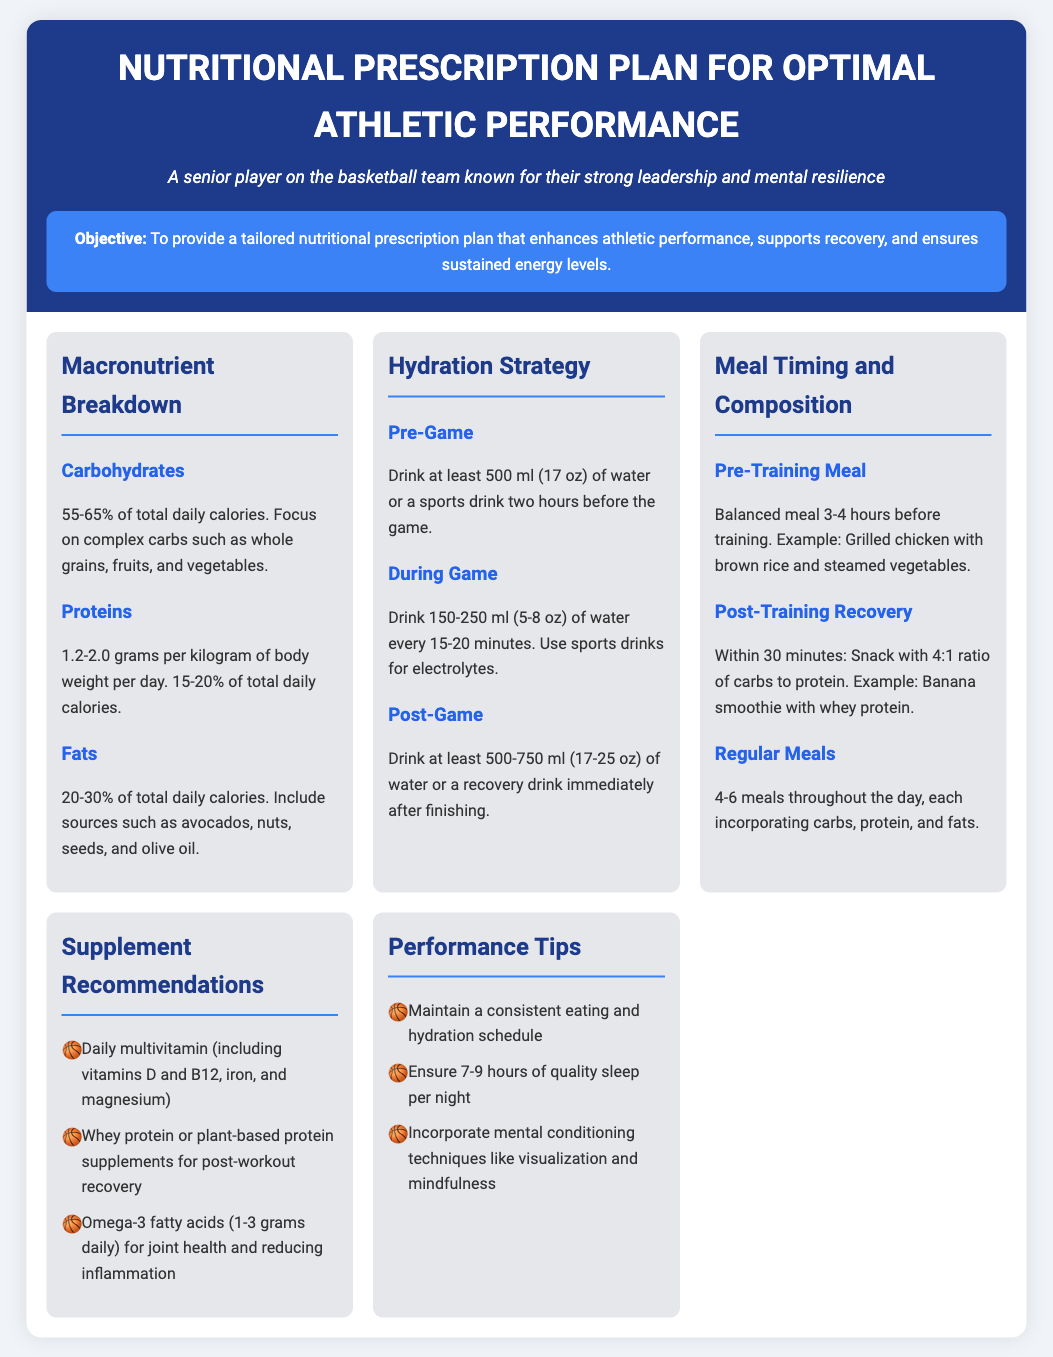What is the percentage of carbohydrates recommended? The document states that carbohydrates should make up 55-65% of total daily calories.
Answer: 55-65% How much protein should be consumed per kilogram of body weight per day? The document indicates that protein intake should be 1.2-2.0 grams per kilogram of body weight per day.
Answer: 1.2-2.0 grams What should be drunk two hours before a game? According to the document, at least 500 ml (17 oz) of water or a sports drink is recommended to be consumed two hours before a game.
Answer: 500 ml How many meals should be consumed throughout the day? The document recommends 4-6 meals throughout the day.
Answer: 4-6 meals What is the ratio of carbs to protein for a post-training recovery snack? The document specifies a 4:1 ratio of carbs to protein for a post-training recovery snack.
Answer: 4:1 What type of supplement is recommended for joint health? The document suggests Omega-3 fatty acids for joint health and reducing inflammation.
Answer: Omega-3 fatty acids What is an effective mental conditioning technique mentioned? The document includes visualization as an effective mental conditioning technique.
Answer: Visualization How many hours of quality sleep is recommended per night? The document advises ensuring 7-9 hours of quality sleep per night.
Answer: 7-9 hours 